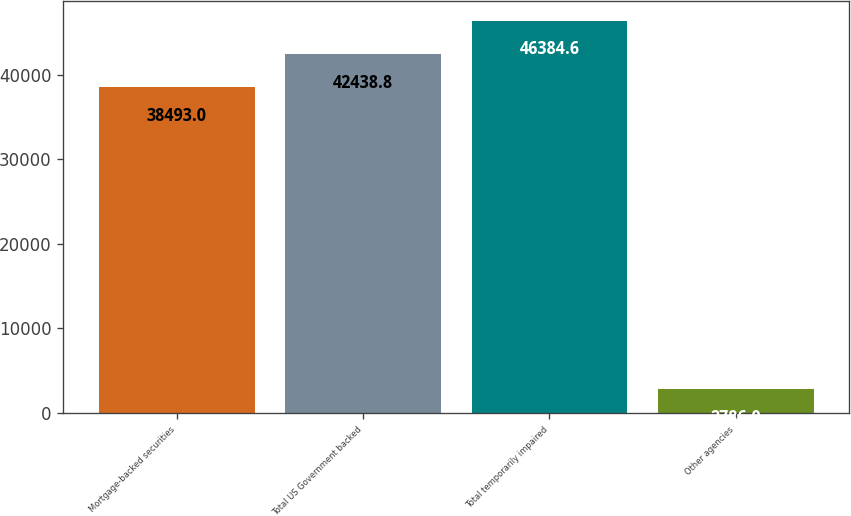<chart> <loc_0><loc_0><loc_500><loc_500><bar_chart><fcel>Mortgage-backed securities<fcel>Total US Government backed<fcel>Total temporarily impaired<fcel>Other agencies<nl><fcel>38493<fcel>42438.8<fcel>46384.6<fcel>2786<nl></chart> 